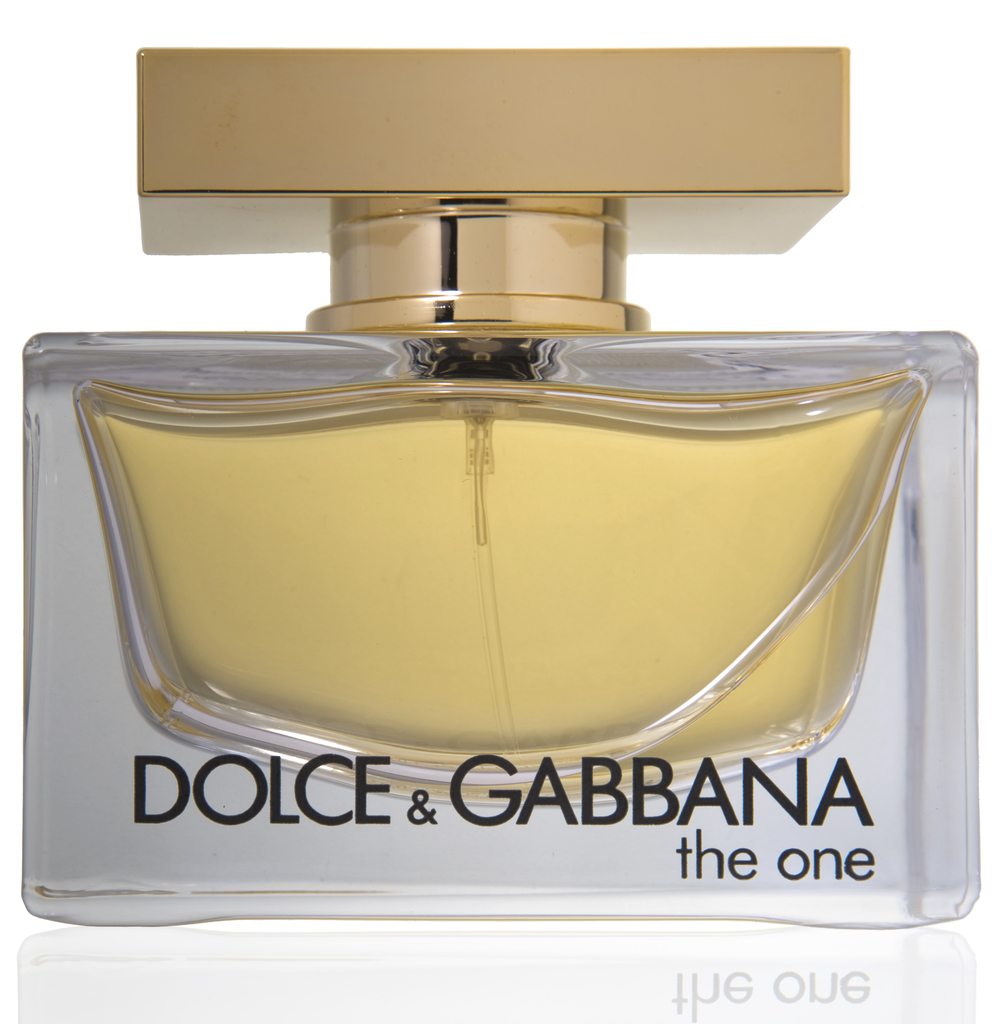Write a detailed description of the given image. The image features a perfume bottle from the renowned designer Dolce & Gabbana, specifically their fragrance 'The One'. The bottle is modern and elegant, boasting a geometric rectangular shape. It is constructed from transparent glass, allowing the warm yellow hue of the perfume to be fully visible, complimenting the overall sophisticated aesthetic. The bottle's cap, a striking golden rectangle, adds a touch of opulence. The simple yet bold black text stating the brand and perfume name on the front enhances the bottle’s appeal, promising a scent as luxurious as its container implies, set against a crisp, clean white background that highlights its sleek design. 